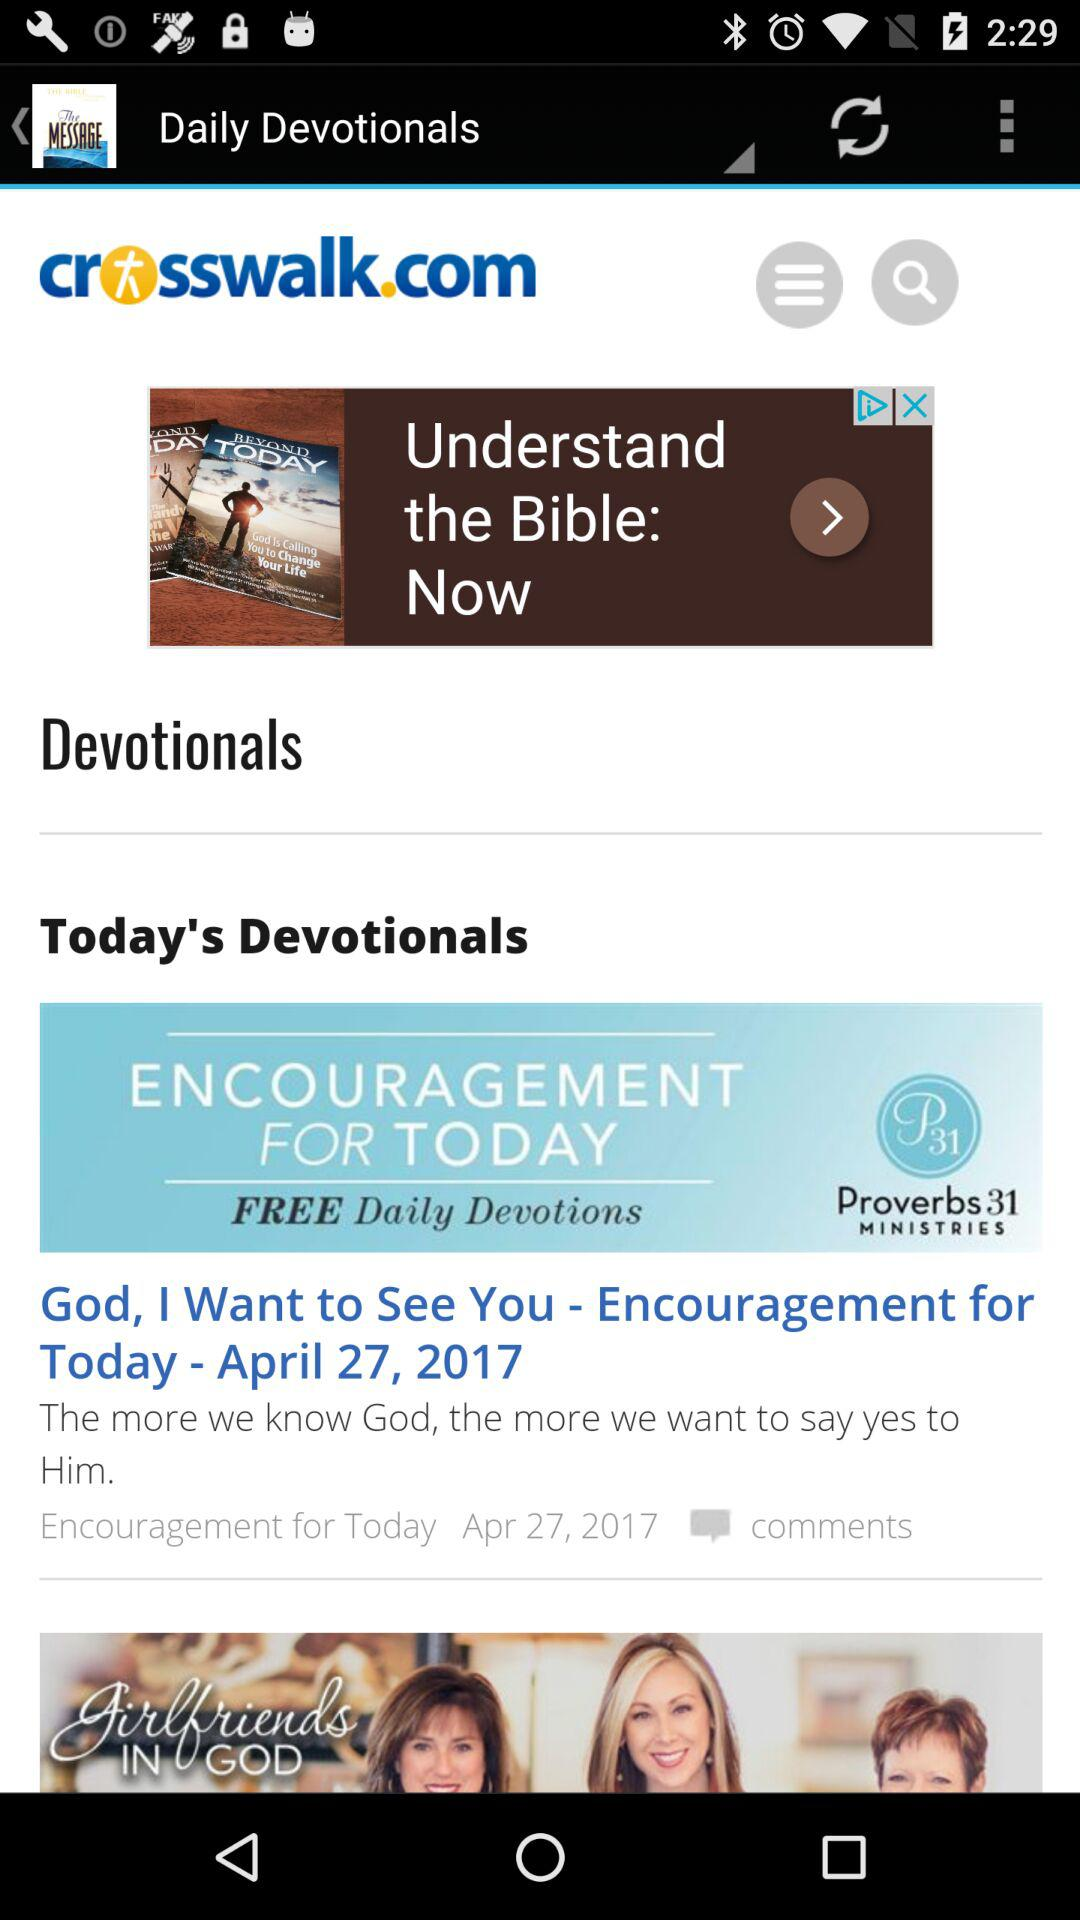What is the date mentioned in "Today's Devotionals"? The date mentioned in "Today's Devotionals" is April 27, 2017. 